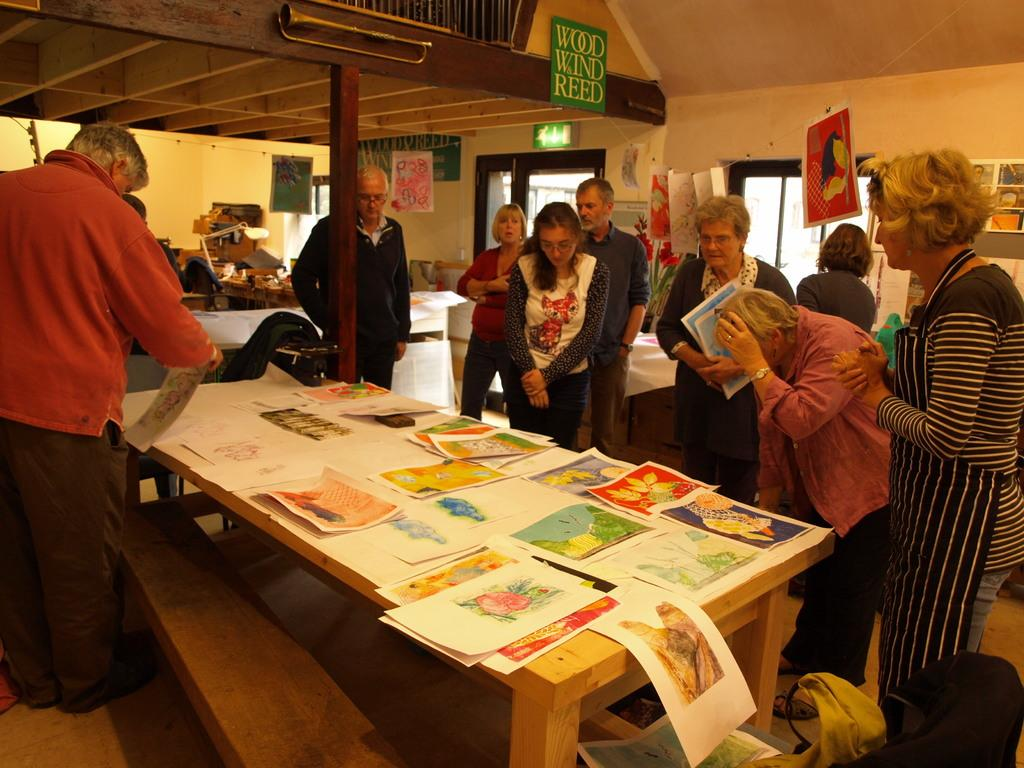How many people are in the image? There is a group of people in the image. What are the people doing in the image? The people are standing and watching papers on a table. What can be seen in the background of the image? There is a table, a light, the roof, musical instruments, and boards visible in the background of the image. What type of rod is being used by the people to hold the papers in the image? There is no rod visible in the image; the people are simply watching papers on a table. 